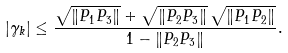Convert formula to latex. <formula><loc_0><loc_0><loc_500><loc_500>| \gamma _ { k } | \leq \frac { \sqrt { \| P _ { 1 } P _ { 3 } \| } + \sqrt { \| P _ { 2 } P _ { 3 } \| } \, \sqrt { \| P _ { 1 } P _ { 2 } \| } } { 1 - \| P _ { 2 } P _ { 3 } \| } .</formula> 